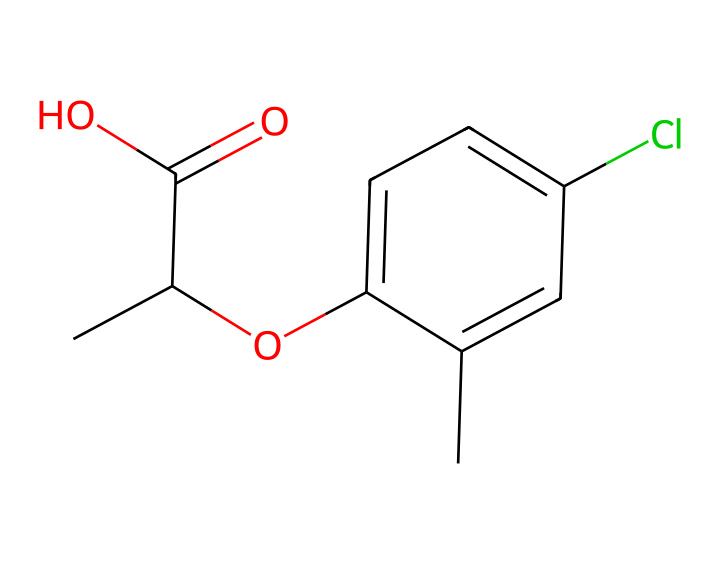What is the molecular formula of mecoprop? To determine the molecular formula, count the number of each type of atom present in the SMILES notation. The structure contains 10 Carbon (C) atoms, 11 Hydrogen (H) atoms, 2 Oxygen (O) atoms, and 1 Chlorine (Cl) atom. Therefore, the overall molecular formula is C10H11ClO2.
Answer: C10H11ClO2 How many rings are present in the chemical structure? Looking at the SMILES representation, we can identify a phenolic ring based on the ‘c’ (aromatic carbon) and ‘cc’ connections. Since only one aromatic ring is evident in the structure, the answer is one.
Answer: 1 What functional groups are present in mecoprop? Analyzing the structure, we find a carboxylic acid group (-COOH) indicated by "C(=O)O" and an ether group indicated by "O" connecting the aromatic ring and aliphatic part. These functional groups contribute to the herbicidal activity of mecoprop.
Answer: carboxylic acid, ether Is mecoprop a selective or non-selective herbicide? Mecoprop is known to be a selective herbicide. This means it targets specific plants while leaving others, such as grass, unharmed. The structure's properties play a role in this selectivity.
Answer: selective Which atom in the structure indicates the presence of a halogen? A chlorine atom is present in the structure, represented by the "Cl". This halogen contributes to the herbicide's efficacy and stability.
Answer: Cl How many total bonds are present in the molecule? By analyzing the bonds between the atoms, we can count single and double bonds. In the given structure, there are 11 carbon-hydrogen single bonds, 1 double bond (C=O), and bonds in the aromatic ring. Totaling these gives us 15 bonds overall.
Answer: 15 